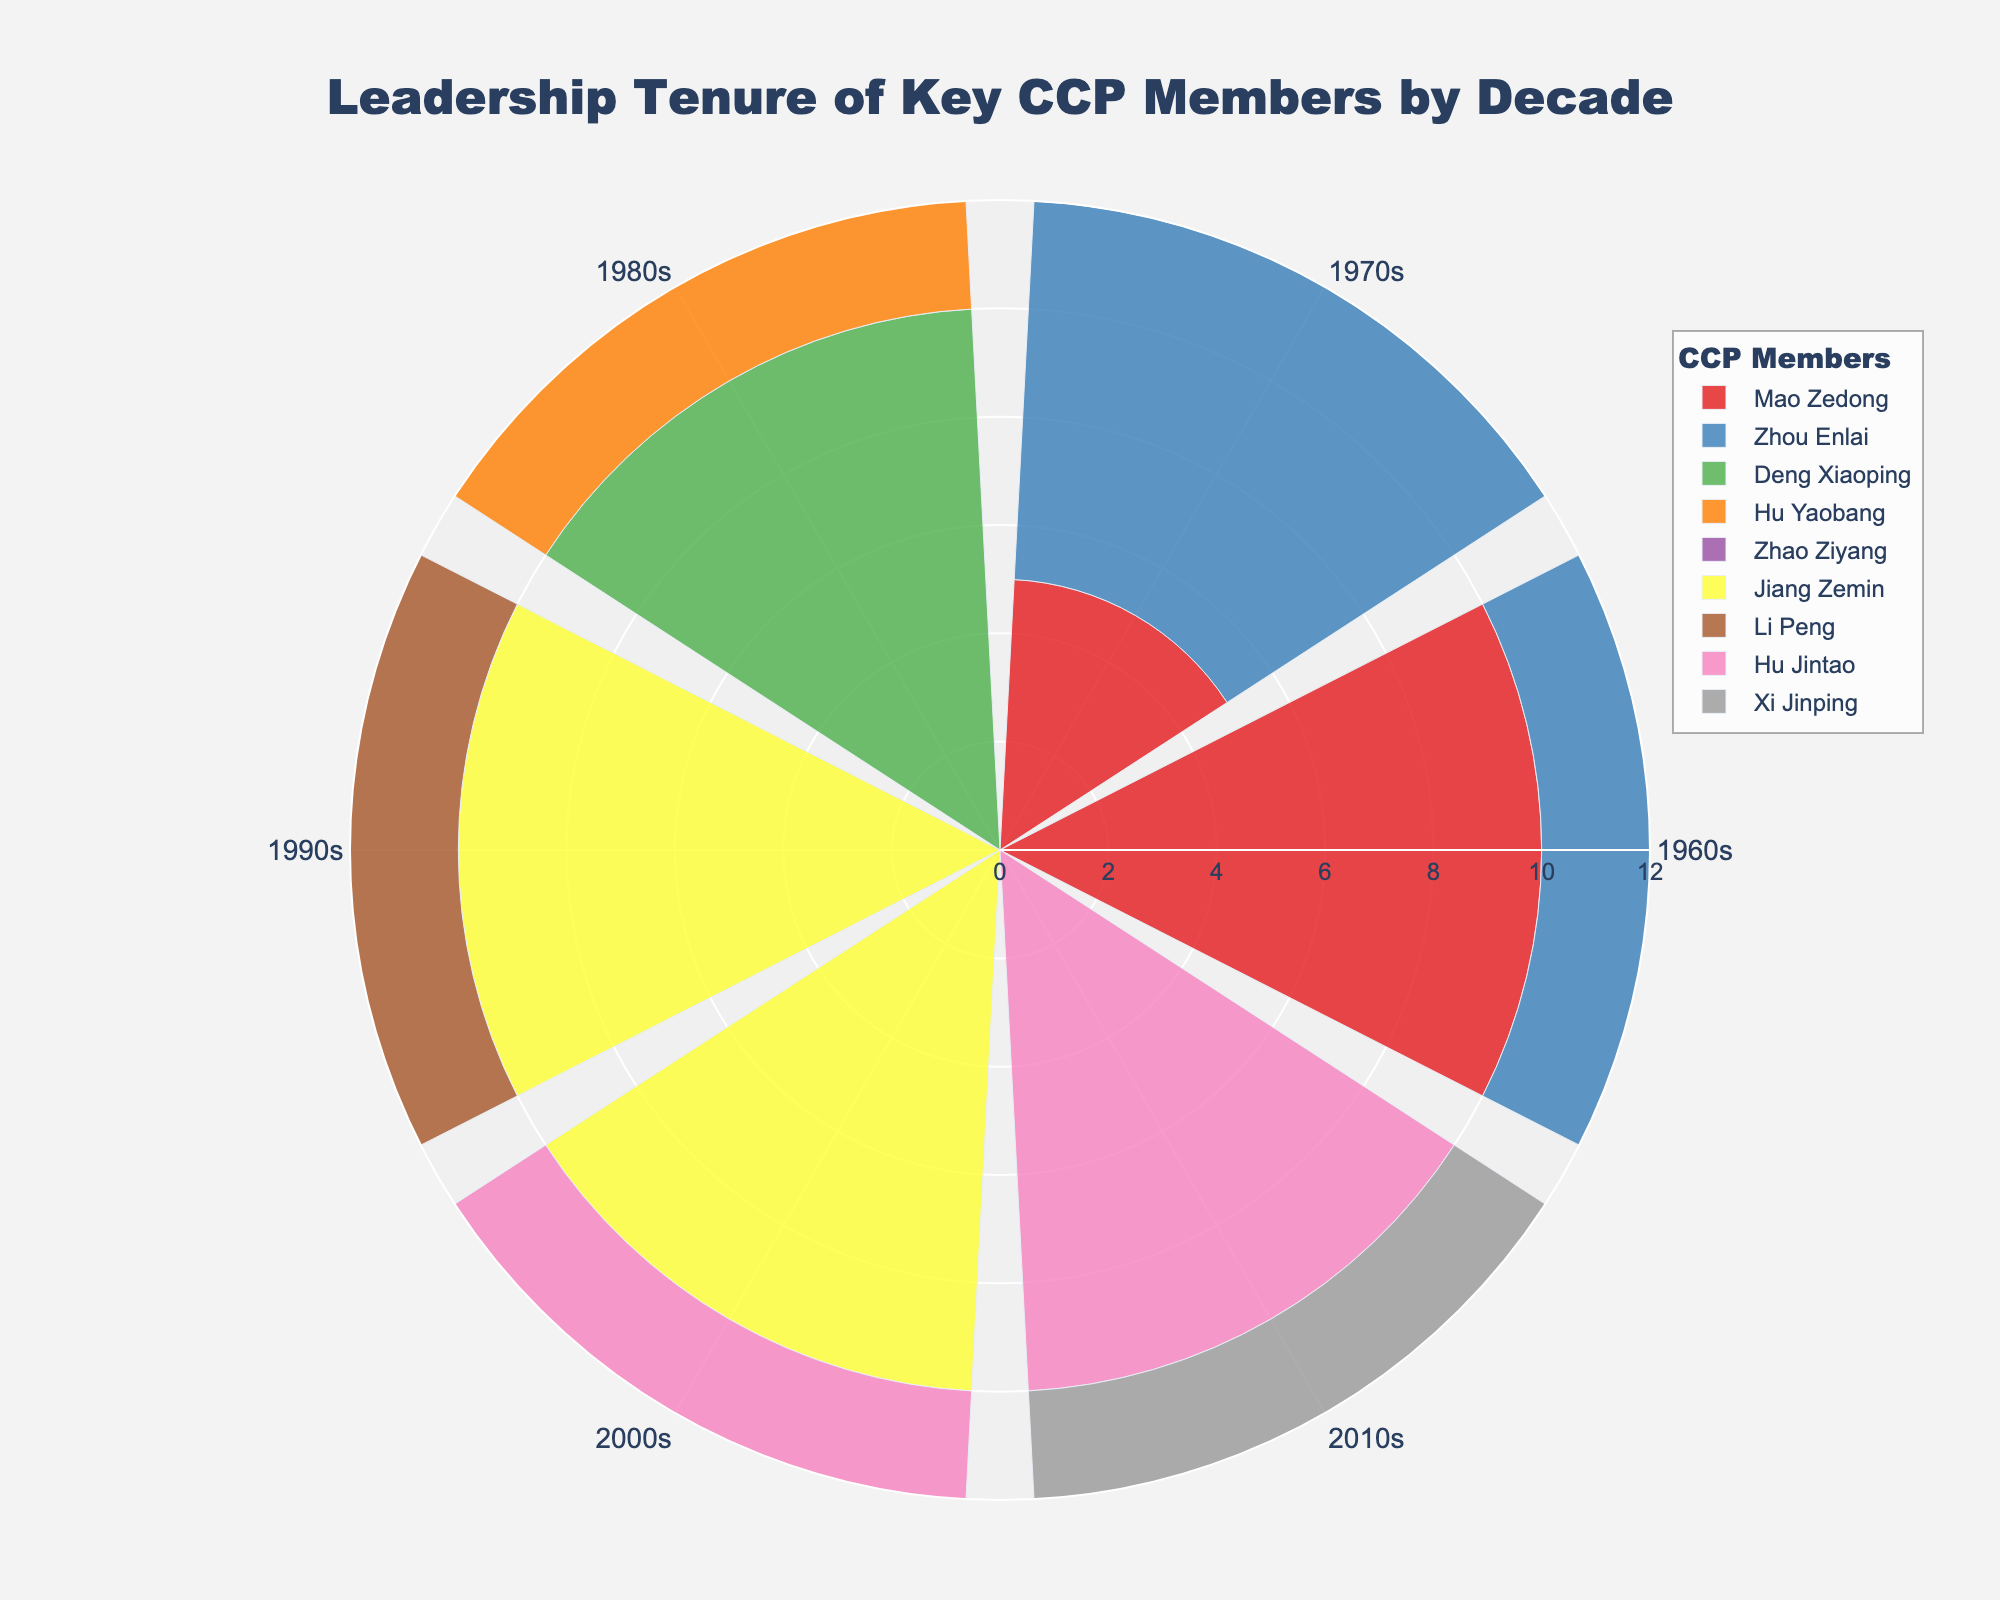What's the title of the figure? The title is displayed prominently at the top of the figure. It reads "Leadership Tenure of Key CCP Members by Decade".
Answer: Leadership Tenure of Key CCP Members by Decade Which CCP member has the longest tenure in the 2010s? By looking at the 2010s segment of the rose chart and comparing the lengths of the bars, we see that both Hu Jintao and Xi Jinping have bars extending to 10 years, indicating they share the longest tenure in the 2010s.
Answer: Hu Jintao and Xi Jinping What is the color of Jiang Zemin's group? The legend on the right side of the figure matches Jiang Zemin with a specific color. According to the information provided, Jiang Zemin's color is yellow.
Answer: Yellow How many decades did Mao Zedong appear in? To determine this, we look at the segments labeled "Mao Zedong" in the figure. He appears in both the 1960s and 1970s.
Answer: 2 What is the average leadership tenure of Mao Zedong across the decades? Mao Zedong's tenures are 10 years in the 1960s and 5 years in the 1970s. We compute the average as (10 + 5) / 2 = 7.5 years.
Answer: 7.5 years Whose leadership tenure decreased from the 1960s to the 1970s? By comparing the lengths of the bars for each member from the 1960s to the 1970s, we find that only Mao Zedong had a decrease from 10 years (1960s) to 5 years (1970s).
Answer: Mao Zedong Which CCP member had the longest constant tenure across two consecutive decades? By inspecting all CCP members and their tenure lengths across two decades, Jiang Zemin and Hu Jintao had 10 years each in the 1990s and 2000s for Jiang Zemin, and Hu Jintao in 2000s and 2010s. Since 10 years is the longest constant tenure, both qualify.
Answer: Jiang Zemin and Hu Jintao What is the maximum leadership tenure shown in the 1980s? Examining the lengths of the bars for the 1980s segment, the maximum tenure is 10 years as denoted by Deng Xiaoping.
Answer: 10 years Compare the total leadership tenure for Zhou Enlai between the 1960s and 1970s. Zhou Enlai's tenures are 8 years in the 1960s and 7 years in the 1970s. Summing these values gives 15 years.
Answer: 15 years Who has the shortest leadership tenure in the 1980s and how long is it? In the 1980s segment, the shortest bar is attributed to Zhao Ziyang, indicating a 5-year tenure.
Answer: Zhao Ziyang - 5 years 